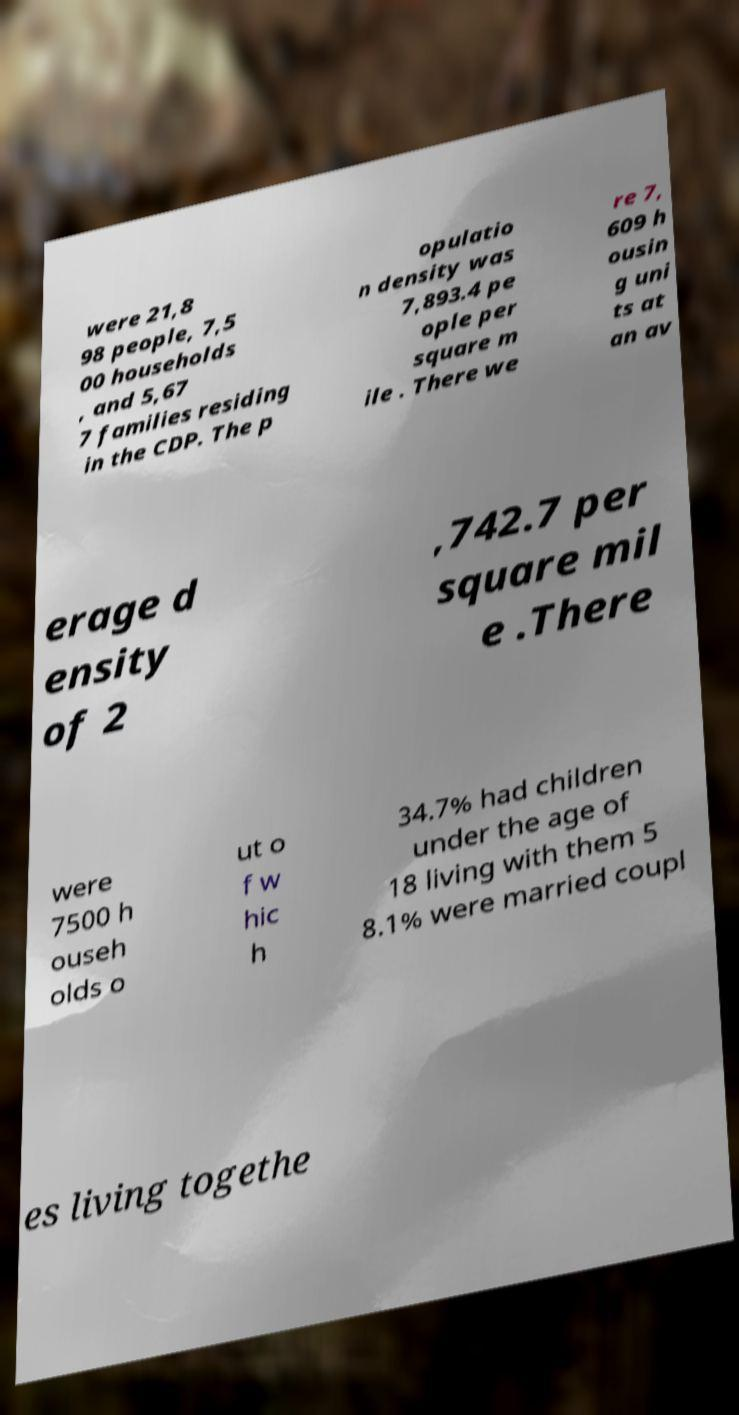There's text embedded in this image that I need extracted. Can you transcribe it verbatim? were 21,8 98 people, 7,5 00 households , and 5,67 7 families residing in the CDP. The p opulatio n density was 7,893.4 pe ople per square m ile . There we re 7, 609 h ousin g uni ts at an av erage d ensity of 2 ,742.7 per square mil e .There were 7500 h ouseh olds o ut o f w hic h 34.7% had children under the age of 18 living with them 5 8.1% were married coupl es living togethe 